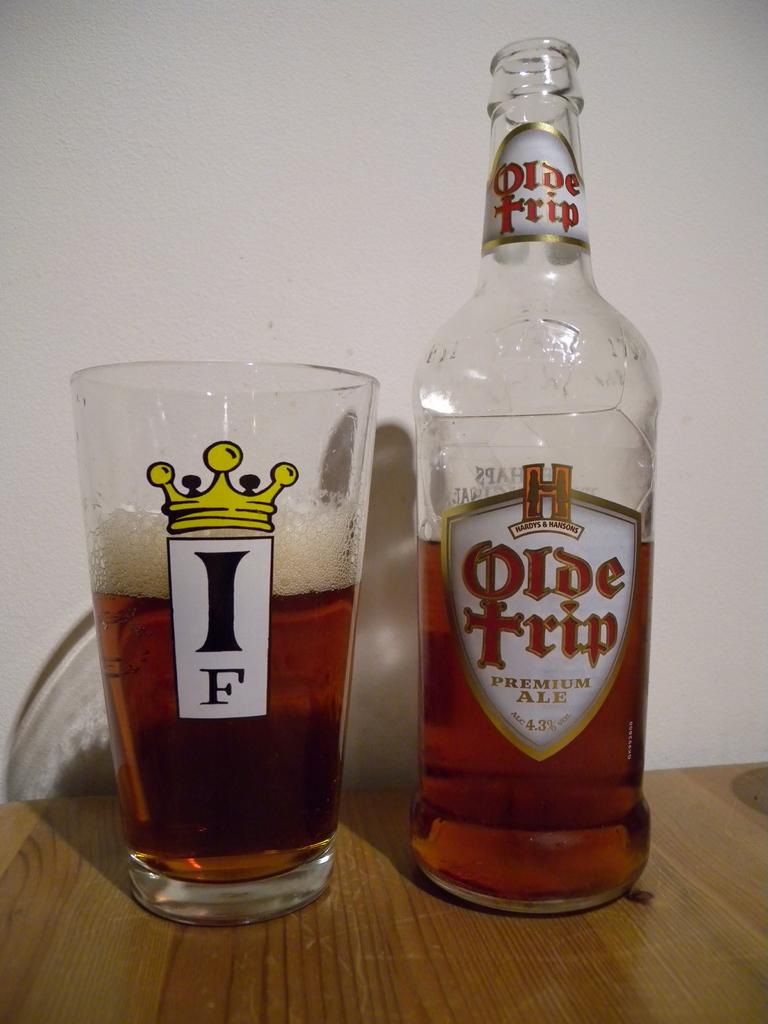<image>
Render a clear and concise summary of the photo. An Olde Trip bottle sits next to a glass. 